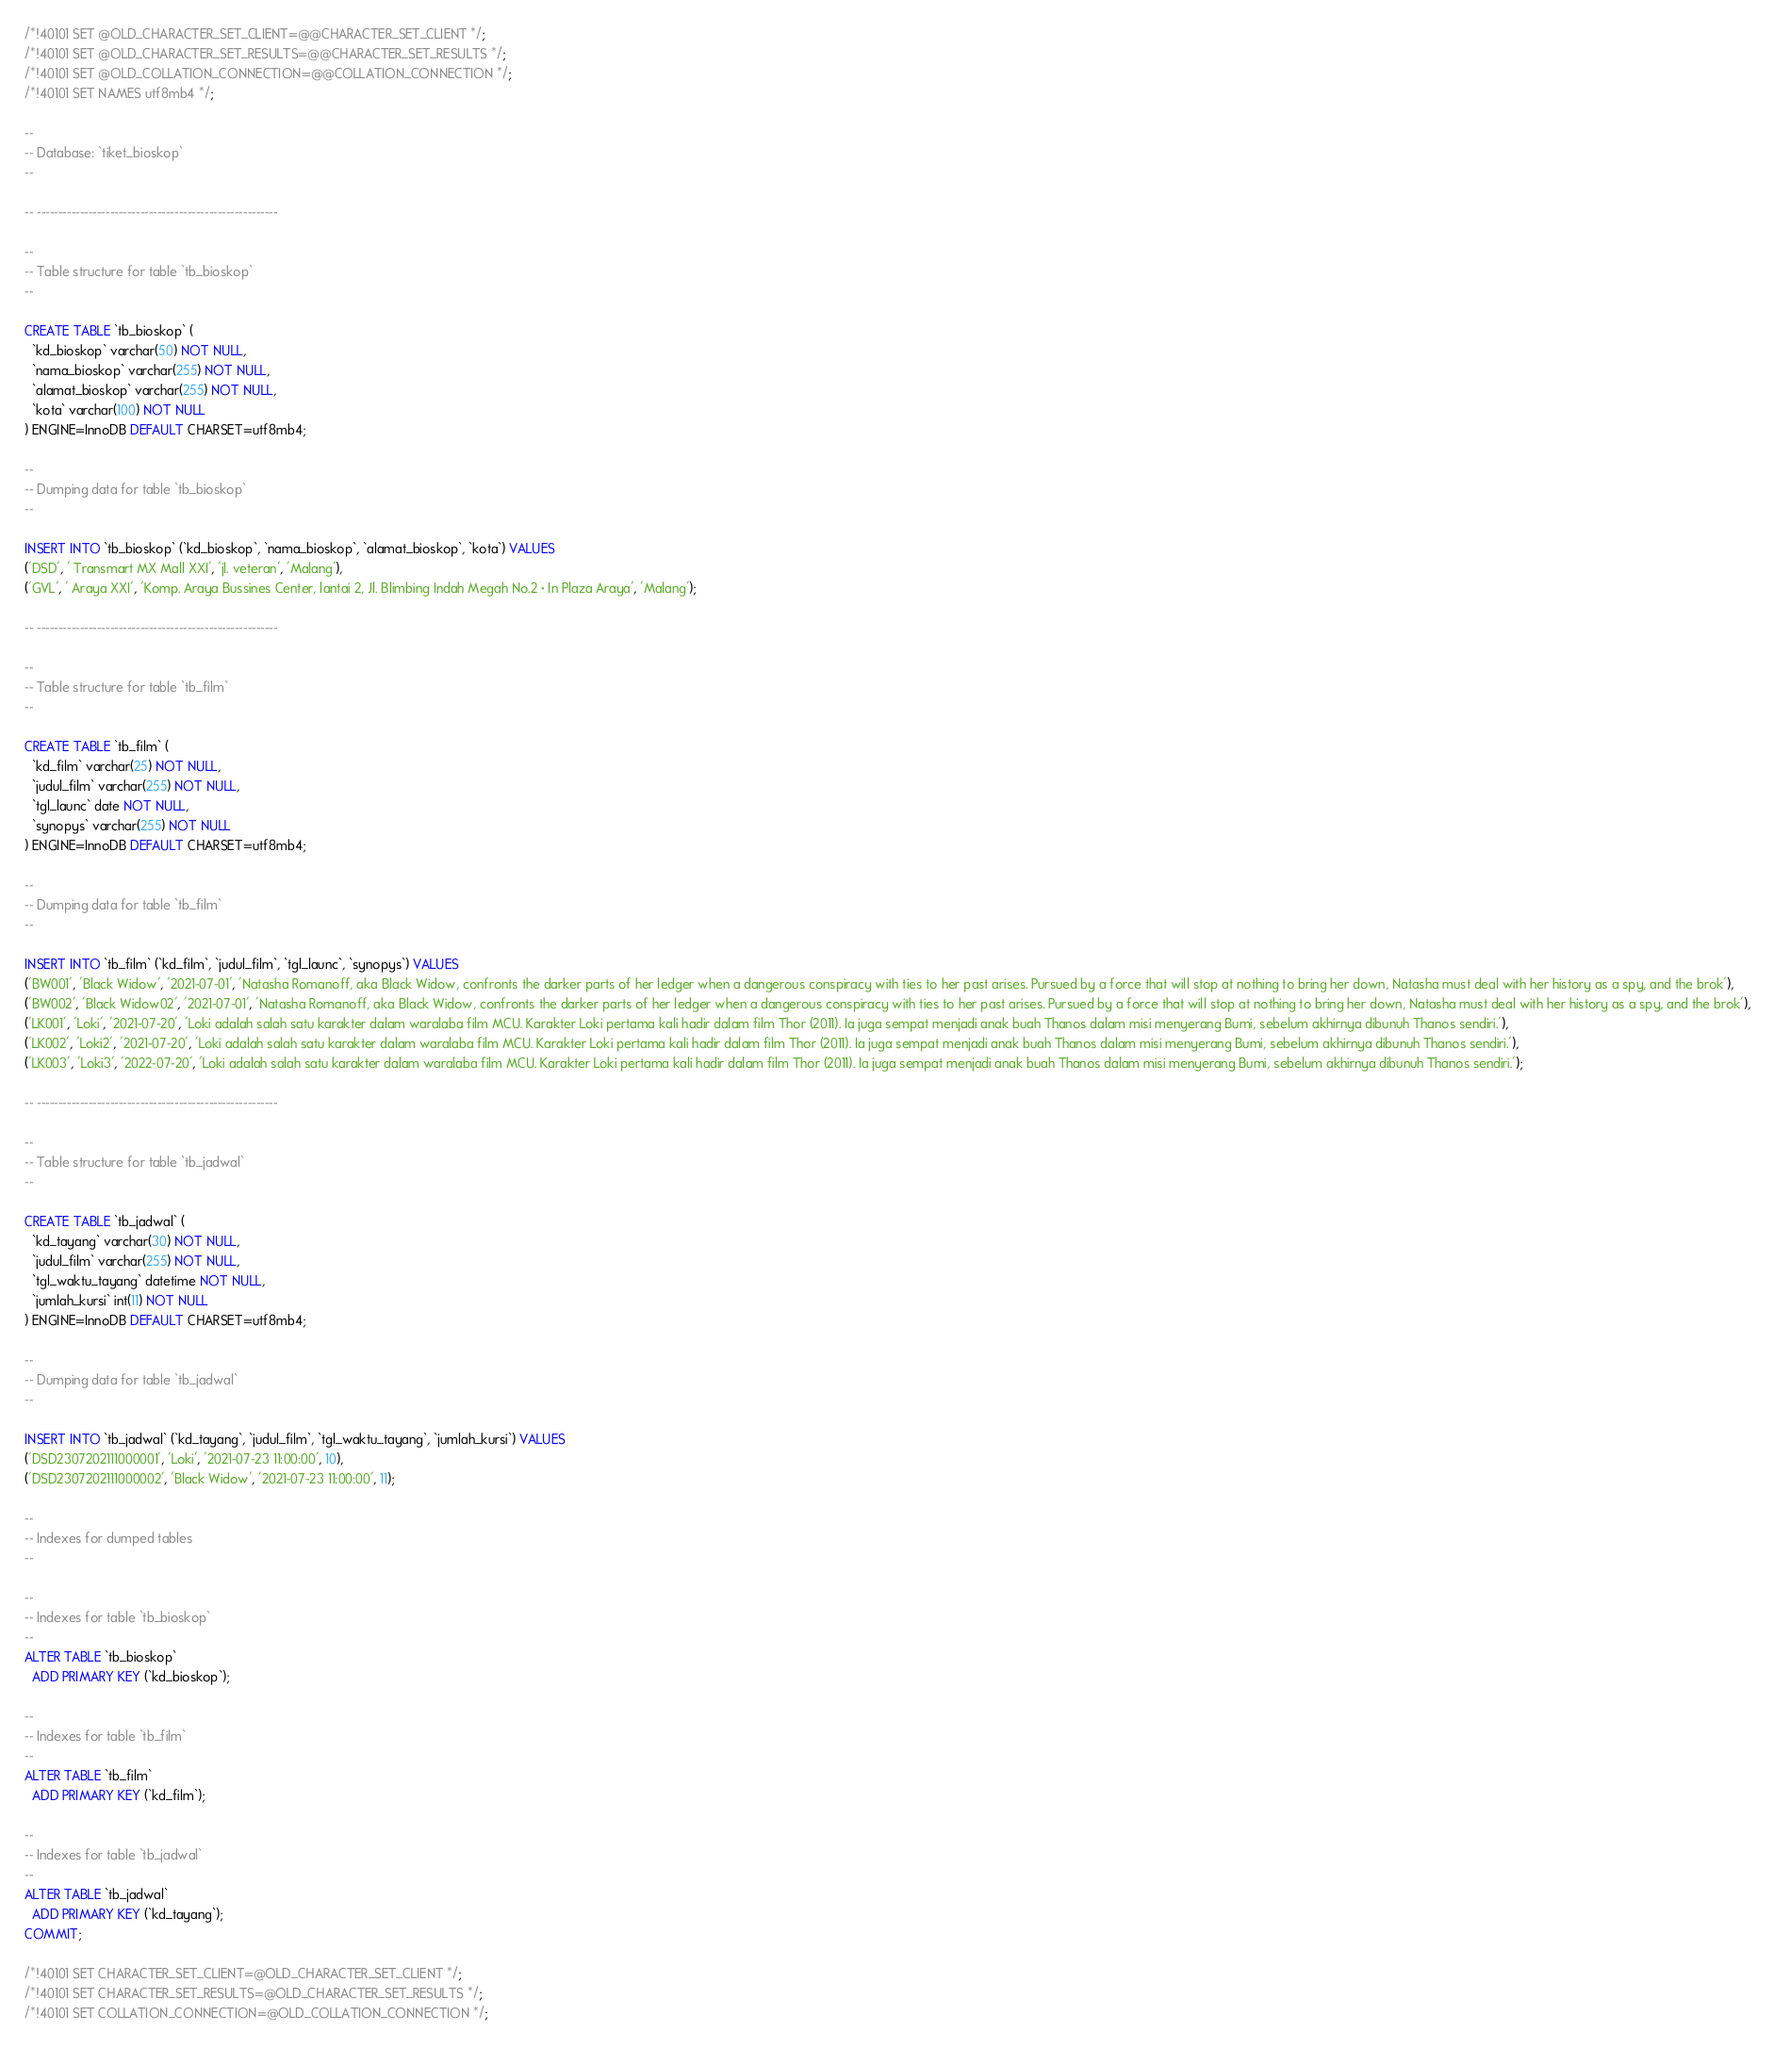<code> <loc_0><loc_0><loc_500><loc_500><_SQL_>
/*!40101 SET @OLD_CHARACTER_SET_CLIENT=@@CHARACTER_SET_CLIENT */;
/*!40101 SET @OLD_CHARACTER_SET_RESULTS=@@CHARACTER_SET_RESULTS */;
/*!40101 SET @OLD_COLLATION_CONNECTION=@@COLLATION_CONNECTION */;
/*!40101 SET NAMES utf8mb4 */;

--
-- Database: `tiket_bioskop`
--

-- --------------------------------------------------------

--
-- Table structure for table `tb_bioskop`
--

CREATE TABLE `tb_bioskop` (
  `kd_bioskop` varchar(50) NOT NULL,
  `nama_bioskop` varchar(255) NOT NULL,
  `alamat_bioskop` varchar(255) NOT NULL,
  `kota` varchar(100) NOT NULL
) ENGINE=InnoDB DEFAULT CHARSET=utf8mb4;

--
-- Dumping data for table `tb_bioskop`
--

INSERT INTO `tb_bioskop` (`kd_bioskop`, `nama_bioskop`, `alamat_bioskop`, `kota`) VALUES
('DSD', ' Transmart MX Mall XXI', 'jl. veteran', 'Malang'),
('GVL', ' Araya XXI', 'Komp. Araya Bussines Center, lantai 2, Jl. Blimbing Indah Megah No.2 · In Plaza Araya', 'Malang');

-- --------------------------------------------------------

--
-- Table structure for table `tb_film`
--

CREATE TABLE `tb_film` (
  `kd_film` varchar(25) NOT NULL,
  `judul_film` varchar(255) NOT NULL,
  `tgl_launc` date NOT NULL,
  `synopys` varchar(255) NOT NULL
) ENGINE=InnoDB DEFAULT CHARSET=utf8mb4;

--
-- Dumping data for table `tb_film`
--

INSERT INTO `tb_film` (`kd_film`, `judul_film`, `tgl_launc`, `synopys`) VALUES
('BW001', 'Black Widow', '2021-07-01', 'Natasha Romanoff, aka Black Widow, confronts the darker parts of her ledger when a dangerous conspiracy with ties to her past arises. Pursued by a force that will stop at nothing to bring her down, Natasha must deal with her history as a spy, and the brok'),
('BW002', 'Black Widow02', '2021-07-01', 'Natasha Romanoff, aka Black Widow, confronts the darker parts of her ledger when a dangerous conspiracy with ties to her past arises. Pursued by a force that will stop at nothing to bring her down, Natasha must deal with her history as a spy, and the brok'),
('LK001', 'Loki', '2021-07-20', 'Loki adalah salah satu karakter dalam waralaba film MCU. Karakter Loki pertama kali hadir dalam film Thor (2011). Ia juga sempat menjadi anak buah Thanos dalam misi menyerang Bumi, sebelum akhirnya dibunuh Thanos sendiri.'),
('LK002', 'Loki2', '2021-07-20', 'Loki adalah salah satu karakter dalam waralaba film MCU. Karakter Loki pertama kali hadir dalam film Thor (2011). Ia juga sempat menjadi anak buah Thanos dalam misi menyerang Bumi, sebelum akhirnya dibunuh Thanos sendiri.'),
('LK003', 'Loki3', '2022-07-20', 'Loki adalah salah satu karakter dalam waralaba film MCU. Karakter Loki pertama kali hadir dalam film Thor (2011). Ia juga sempat menjadi anak buah Thanos dalam misi menyerang Bumi, sebelum akhirnya dibunuh Thanos sendiri.');

-- --------------------------------------------------------

--
-- Table structure for table `tb_jadwal`
--

CREATE TABLE `tb_jadwal` (
  `kd_tayang` varchar(30) NOT NULL,
  `judul_film` varchar(255) NOT NULL,
  `tgl_waktu_tayang` datetime NOT NULL,
  `jumlah_kursi` int(11) NOT NULL
) ENGINE=InnoDB DEFAULT CHARSET=utf8mb4;

--
-- Dumping data for table `tb_jadwal`
--

INSERT INTO `tb_jadwal` (`kd_tayang`, `judul_film`, `tgl_waktu_tayang`, `jumlah_kursi`) VALUES
('DSD2307202111000001', 'Loki', '2021-07-23 11:00:00', 10),
('DSD2307202111000002', 'Black Widow', '2021-07-23 11:00:00', 11);

--
-- Indexes for dumped tables
--

--
-- Indexes for table `tb_bioskop`
--
ALTER TABLE `tb_bioskop`
  ADD PRIMARY KEY (`kd_bioskop`);

--
-- Indexes for table `tb_film`
--
ALTER TABLE `tb_film`
  ADD PRIMARY KEY (`kd_film`);

--
-- Indexes for table `tb_jadwal`
--
ALTER TABLE `tb_jadwal`
  ADD PRIMARY KEY (`kd_tayang`);
COMMIT;

/*!40101 SET CHARACTER_SET_CLIENT=@OLD_CHARACTER_SET_CLIENT */;
/*!40101 SET CHARACTER_SET_RESULTS=@OLD_CHARACTER_SET_RESULTS */;
/*!40101 SET COLLATION_CONNECTION=@OLD_COLLATION_CONNECTION */;
</code> 